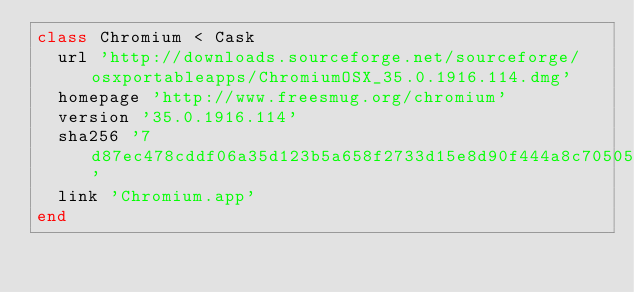<code> <loc_0><loc_0><loc_500><loc_500><_Ruby_>class Chromium < Cask
  url 'http://downloads.sourceforge.net/sourceforge/osxportableapps/ChromiumOSX_35.0.1916.114.dmg'
  homepage 'http://www.freesmug.org/chromium'
  version '35.0.1916.114'
  sha256 '7d87ec478cddf06a35d123b5a658f2733d15e8d90f444a8c70505a66655cf24d'
  link 'Chromium.app'
end
</code> 